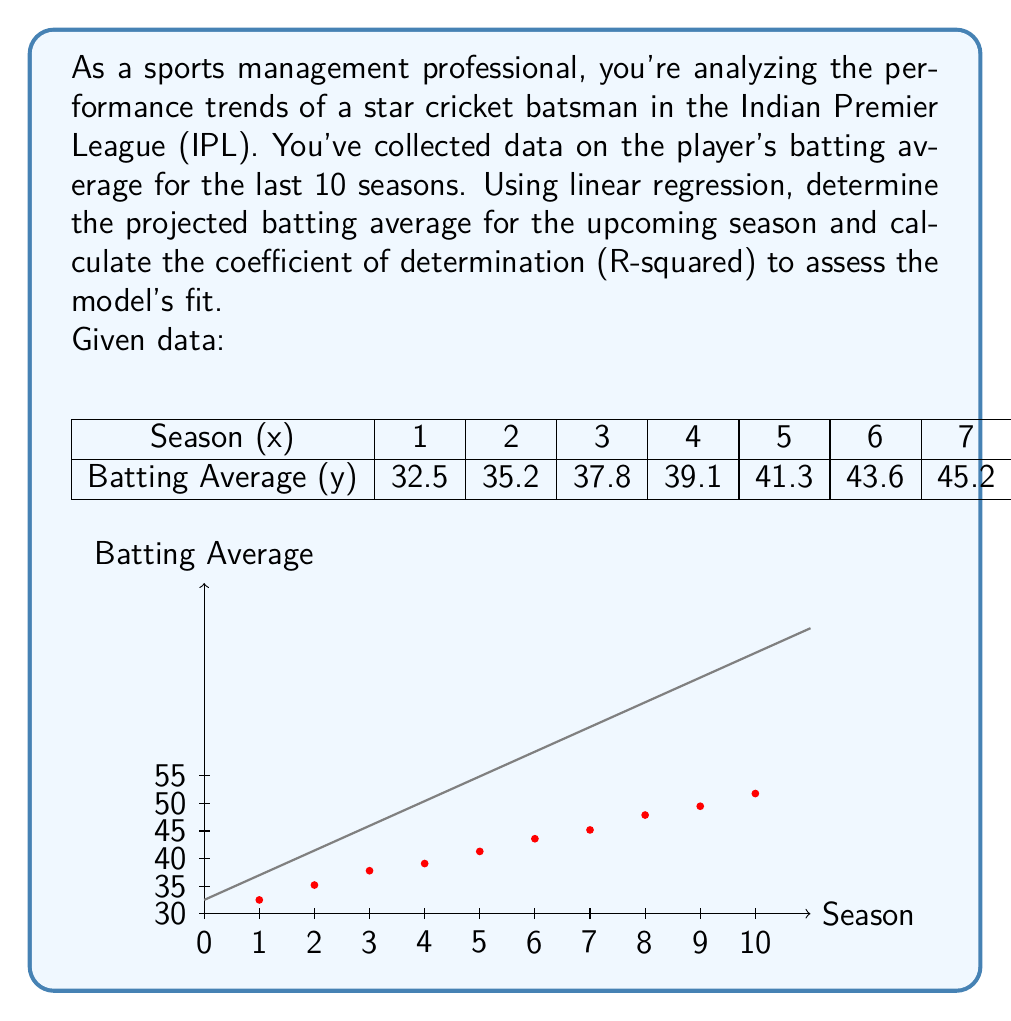Can you answer this question? To solve this problem, we'll use linear regression and calculate the necessary statistics:

1. Calculate the means of x and y:
   $\bar{x} = \frac{\sum x}{n} = \frac{55}{10} = 5.5$
   $\bar{y} = \frac{\sum y}{n} = \frac{423.9}{10} = 42.39$

2. Calculate the slope (m) of the regression line:
   $m = \frac{\sum (x - \bar{x})(y - \bar{y})}{\sum (x - \bar{x})^2}$

   $\sum (x - \bar{x})(y - \bar{y}) = 412.95$
   $\sum (x - \bar{x})^2 = 82.5$

   $m = \frac{412.95}{82.5} = 5.005$

3. Calculate the y-intercept (b):
   $b = \bar{y} - m\bar{x} = 42.39 - 5.005 * 5.5 = 14.8625$

4. The regression equation is:
   $y = 5.005x + 14.8625$

5. Project the batting average for the upcoming season (x = 11):
   $y = 5.005 * 11 + 14.8625 = 69.9175$

6. Calculate R-squared:
   $R^2 = \frac{(\sum (x - \bar{x})(y - \bar{y}))^2}{\sum (x - \bar{x})^2 \sum (y - \bar{y})^2}$

   $\sum (y - \bar{y})^2 = 641.1379$

   $R^2 = \frac{412.95^2}{82.5 * 641.1379} = 0.9892$

The projected batting average for the upcoming season is 69.9175, and the R-squared value is 0.9892, indicating a very good fit of the linear model to the data.
Answer: Projected batting average: 69.92, R-squared: 0.9892 